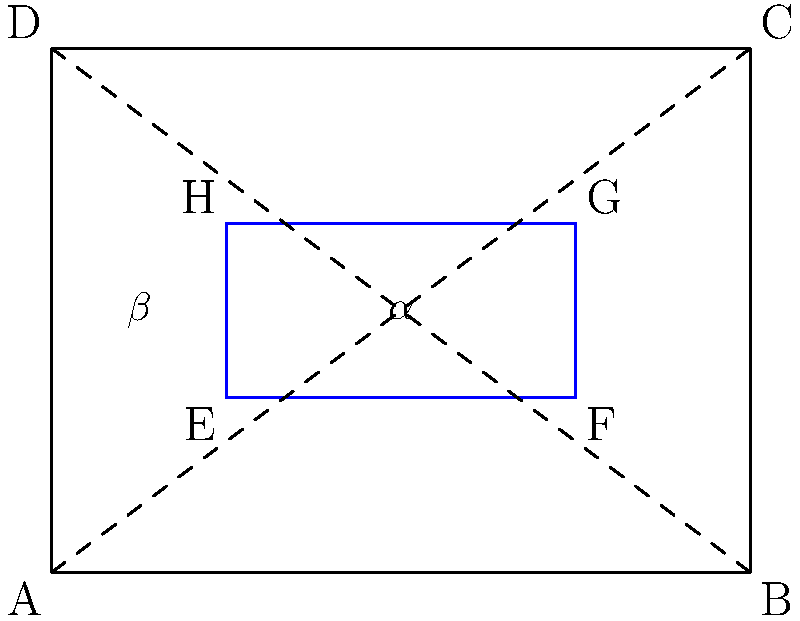In this traditional weaving pattern, the blue rectangle represents a common motif. If the outer rectangle ABCD represents the entire textile, and the diagonals AC and BD intersect at the center of both rectangles, what is the relationship between angles $\alpha$ and $\beta$? Let's approach this step-by-step:

1) First, note that the diagonals AC and BD intersect at the center of both rectangles. This means that the blue rectangle is similar to the outer rectangle ABCD.

2) In a rectangle, diagonals bisect each other. This means that the point of intersection of AC and BD is the center of both rectangles.

3) The diagonals of a rectangle are also equal in length and bisect each other at right angles.

4) Because of the similarity between the two rectangles, the angles formed by the diagonals with the sides of each rectangle are corresponding and thus equal.

5) Angle $\alpha$ is formed by diagonal AC and side EF of the blue rectangle.

6) Angle $\beta$ is formed by diagonal BD and side EH of the blue rectangle.

7) Since the diagonals intersect at right angles, and $\alpha$ and $\beta$ are parts of this right angle, they must be complementary.

8) Complementary angles are two angles that add up to 90°.

Therefore, angles $\alpha$ and $\beta$ are complementary.
Answer: $\alpha$ and $\beta$ are complementary angles 